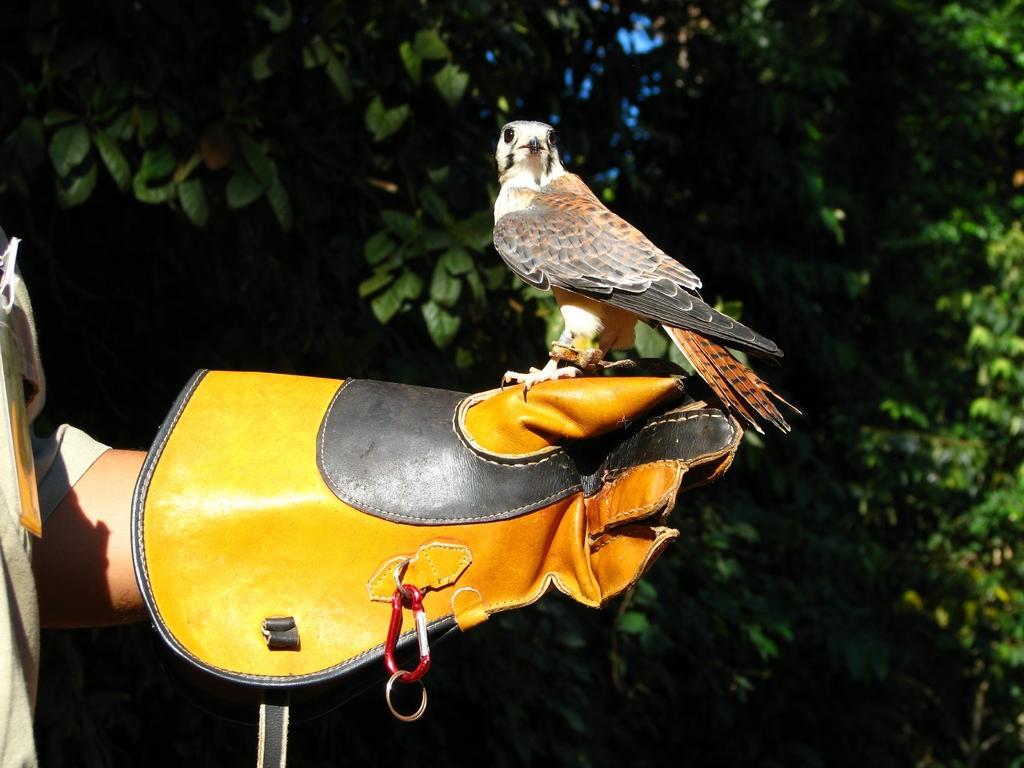Please provide a concise description of this image. In this picture there is a hand of a person with glove, on a glove there is a bird. In the background of the image we can see trees. 